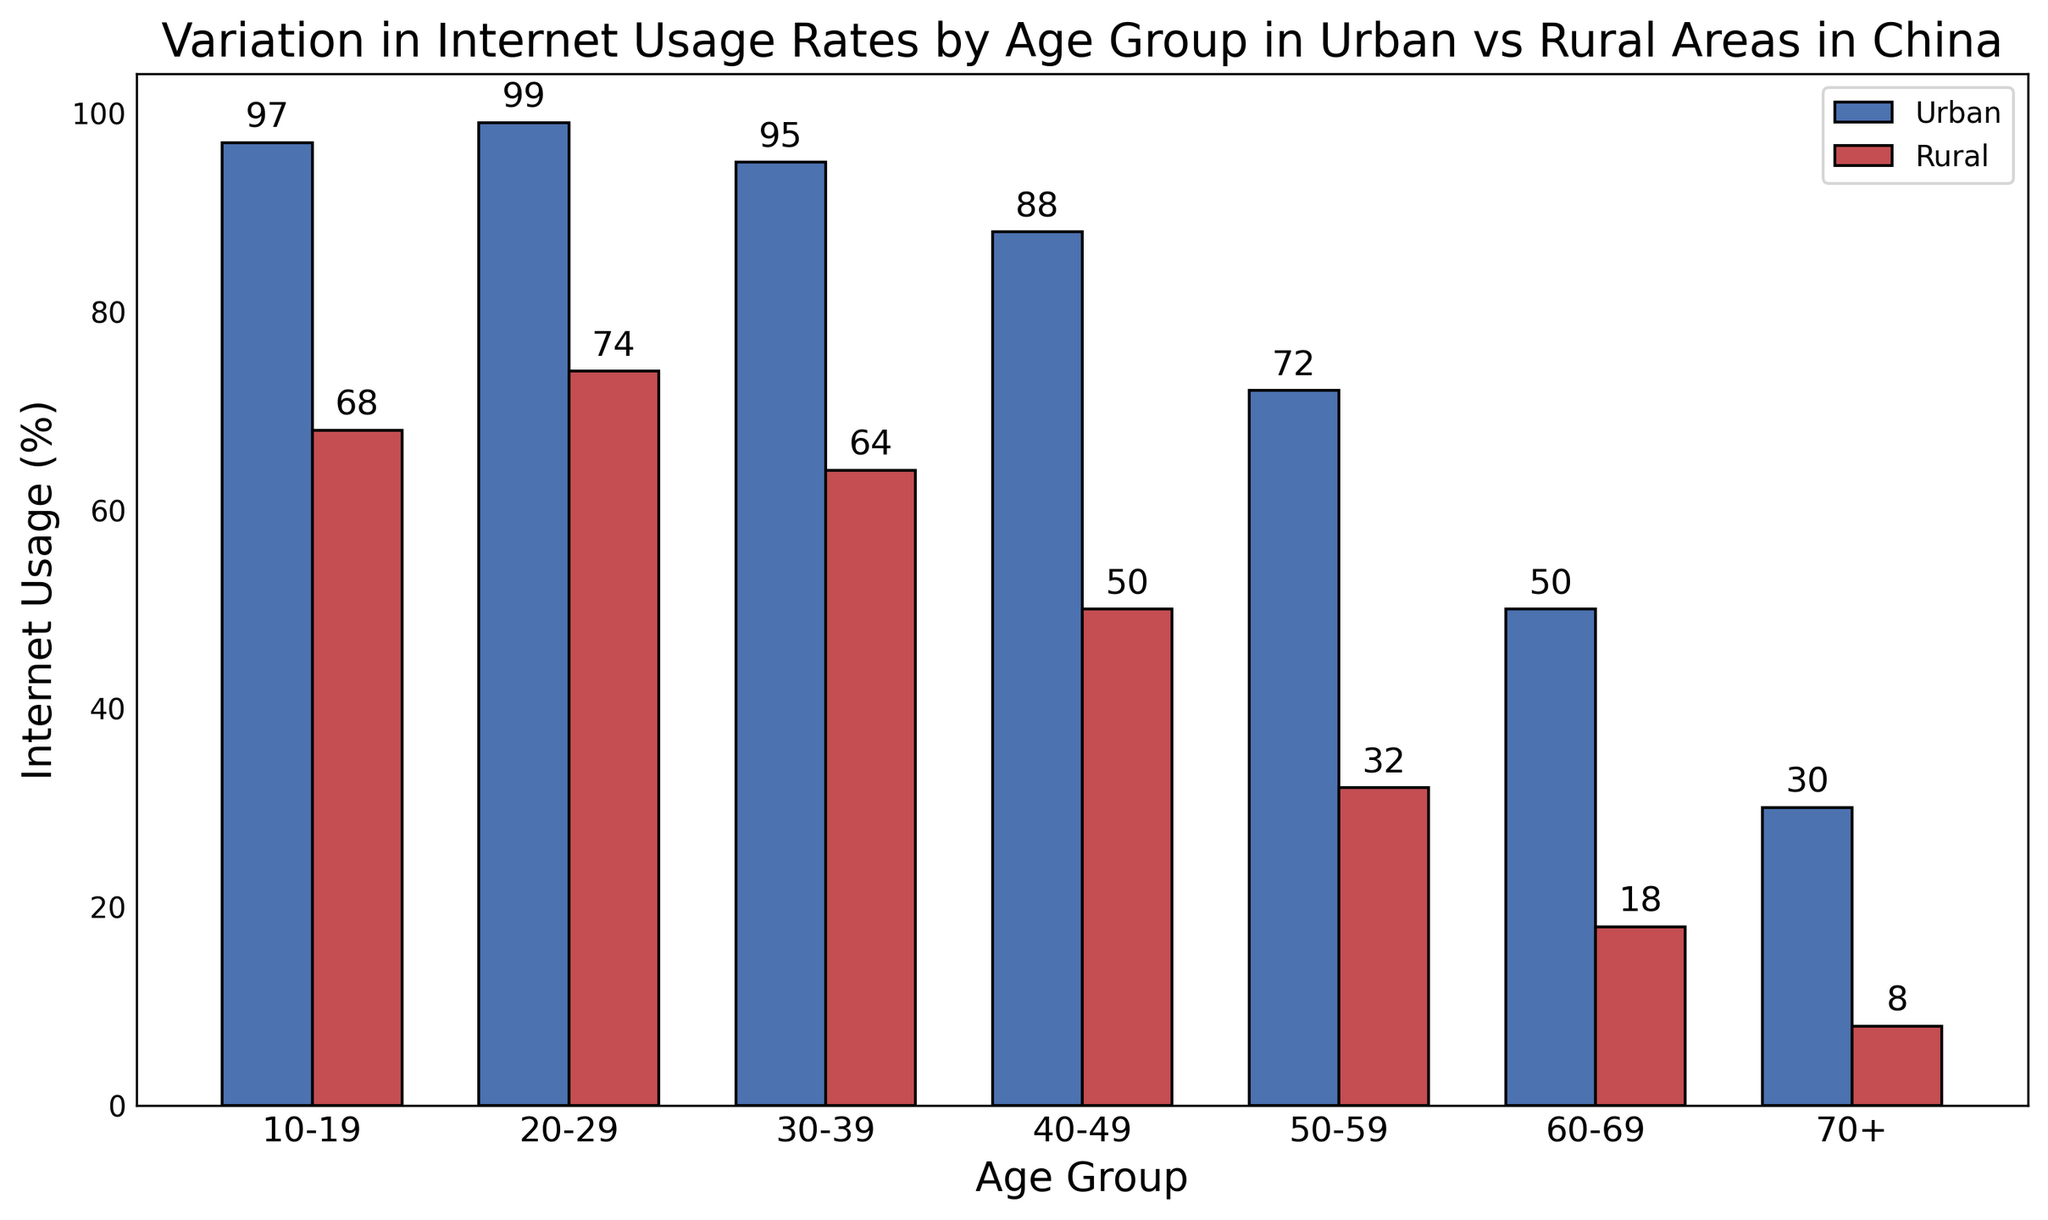Which age group has the highest urban internet usage rate? The highest urban internet usage rate can be determined by looking at the tallest blue bar in the chart. The age group 20-29 has the tallest blue bar, indicating the highest internet usage rate at 99%.
Answer: 20-29 What is the difference in internet usage rates between urban and rural areas for the 50-59 age group? The urban usage rate for the 50-59 age group is 72%, and the rural usage rate is 32%. The difference between them is calculated by subtracting the rural rate from the urban rate: 72% - 32% = 40%.
Answer: 40% How does internet usage in rural areas change as age increases from 10-19 to 70+? In the chart, each red bar represents rural internet usage. Observing the red bars from left to right, the height of the bars decreases as the age group increases, indicating a decline in internet usage from 68% in the 10-19 age group to 8% in the 70+ age group.
Answer: Decreases Which has a greater internet usage rate, urban 40-49 or rural 20-29? By comparing the blue bar for urban 40-49 (88%) and the red bar for rural 20-29 (74%), it is clear that the urban 40-49 age group has a greater internet usage rate.
Answer: Urban 40-49 What is the average internet usage rate across all age groups for urban areas? To find the average urban internet usage rate, sum the urban rates for all age groups and divide by the number of groups: (97% + 99% + 95% + 88% + 72% + 50% + 30%) / 7 = 75.86%.
Answer: 75.86% What is the combined internet usage rate for the 60-69 and 70+ groups in rural areas? Summing the rural internet usage rates for 60-69 (18%) and 70+ (8%) gives: 18% + 8% = 26%.
Answer: 26% How much lower is the rural internet usage rate for the 30-39 age group compared to its urban counterpart? The urban rate for 30-39 is 95%, and the rural rate is 64%. The difference is calculated as: 95% - 64% = 31%.
Answer: 31% Which color bars represent rural internet usage rates? The red bars in the chart represent rural internet usage rates as indicated by the legend.
Answer: Red How does rural internet usage for the 10-19 age group compare to the 40-49 age group? Comparing the heights of the red bars for the 10-19 (68%) and 40-49 (50%) age groups shows that the 10-19 group has higher internet usage.
Answer: 10-19 higher 